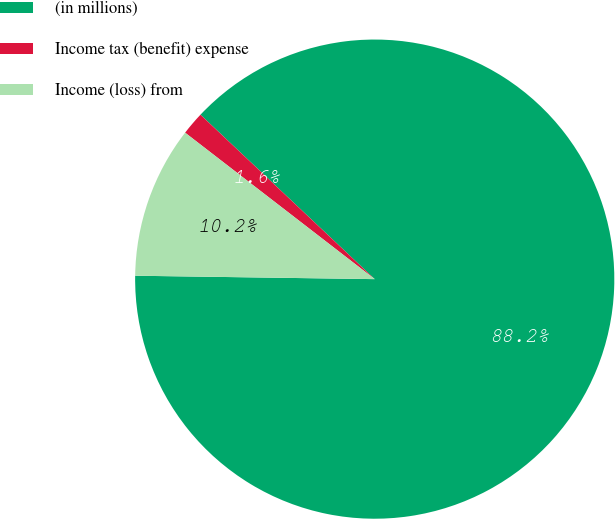Convert chart to OTSL. <chart><loc_0><loc_0><loc_500><loc_500><pie_chart><fcel>(in millions)<fcel>Income tax (benefit) expense<fcel>Income (loss) from<nl><fcel>88.19%<fcel>1.57%<fcel>10.24%<nl></chart> 